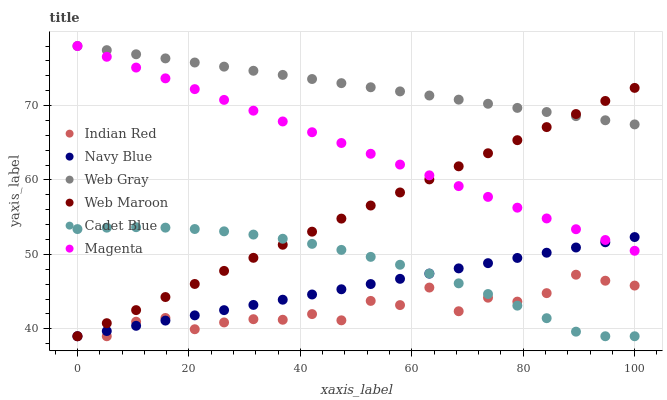Does Indian Red have the minimum area under the curve?
Answer yes or no. Yes. Does Web Gray have the maximum area under the curve?
Answer yes or no. Yes. Does Navy Blue have the minimum area under the curve?
Answer yes or no. No. Does Navy Blue have the maximum area under the curve?
Answer yes or no. No. Is Magenta the smoothest?
Answer yes or no. Yes. Is Indian Red the roughest?
Answer yes or no. Yes. Is Navy Blue the smoothest?
Answer yes or no. No. Is Navy Blue the roughest?
Answer yes or no. No. Does Cadet Blue have the lowest value?
Answer yes or no. Yes. Does Web Gray have the lowest value?
Answer yes or no. No. Does Magenta have the highest value?
Answer yes or no. Yes. Does Navy Blue have the highest value?
Answer yes or no. No. Is Cadet Blue less than Magenta?
Answer yes or no. Yes. Is Web Gray greater than Cadet Blue?
Answer yes or no. Yes. Does Magenta intersect Web Gray?
Answer yes or no. Yes. Is Magenta less than Web Gray?
Answer yes or no. No. Is Magenta greater than Web Gray?
Answer yes or no. No. Does Cadet Blue intersect Magenta?
Answer yes or no. No. 